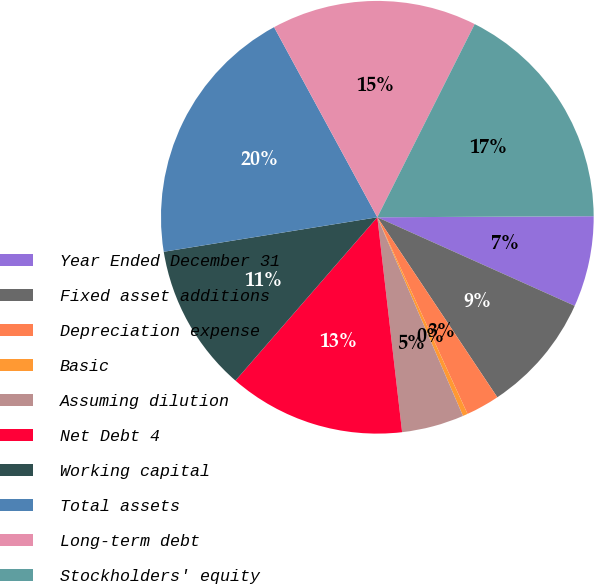<chart> <loc_0><loc_0><loc_500><loc_500><pie_chart><fcel>Year Ended December 31<fcel>Fixed asset additions<fcel>Depreciation expense<fcel>Basic<fcel>Assuming dilution<fcel>Net Debt 4<fcel>Working capital<fcel>Total assets<fcel>Long-term debt<fcel>Stockholders' equity<nl><fcel>6.79%<fcel>8.93%<fcel>2.51%<fcel>0.37%<fcel>4.65%<fcel>13.21%<fcel>11.07%<fcel>19.63%<fcel>15.35%<fcel>17.49%<nl></chart> 